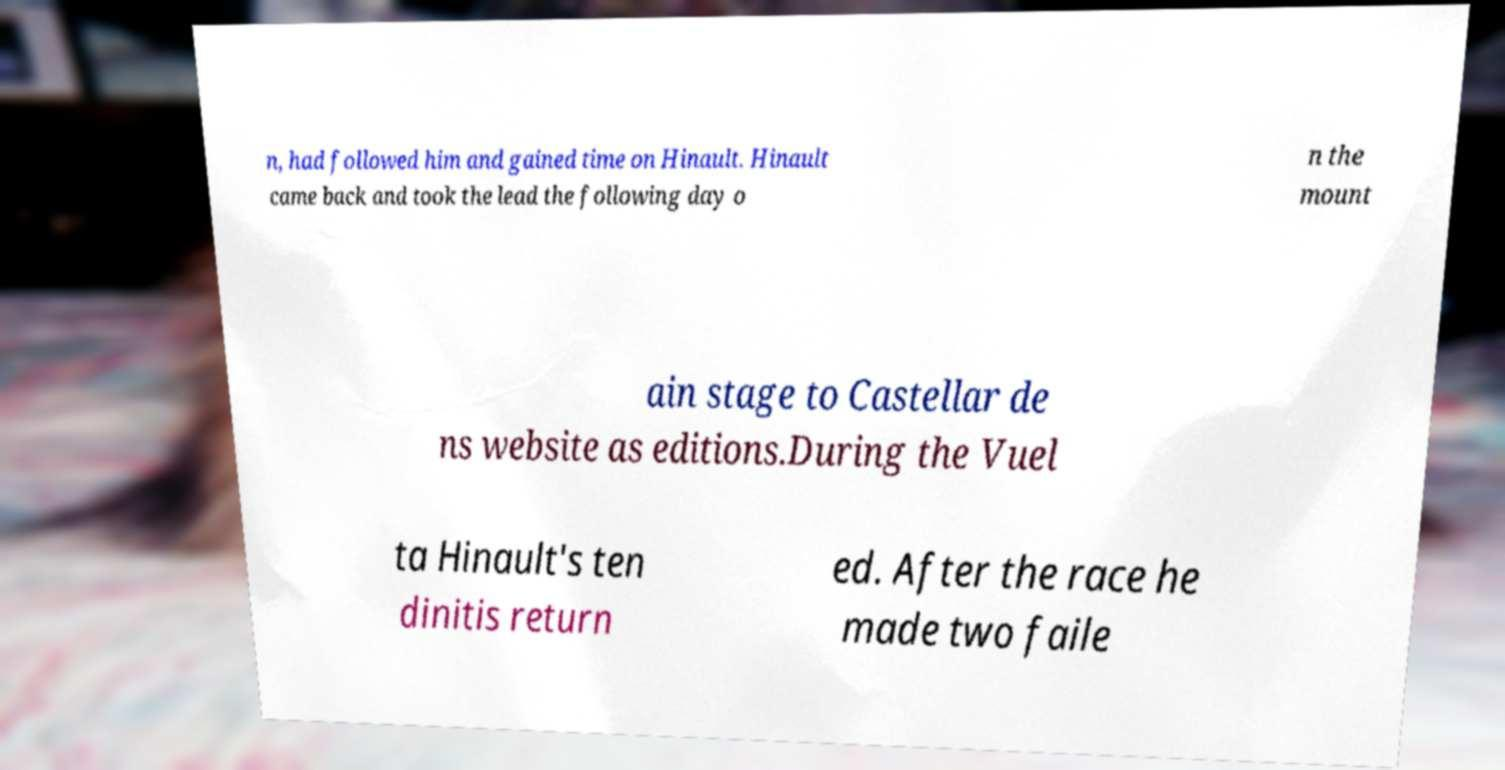Can you accurately transcribe the text from the provided image for me? n, had followed him and gained time on Hinault. Hinault came back and took the lead the following day o n the mount ain stage to Castellar de ns website as editions.During the Vuel ta Hinault's ten dinitis return ed. After the race he made two faile 